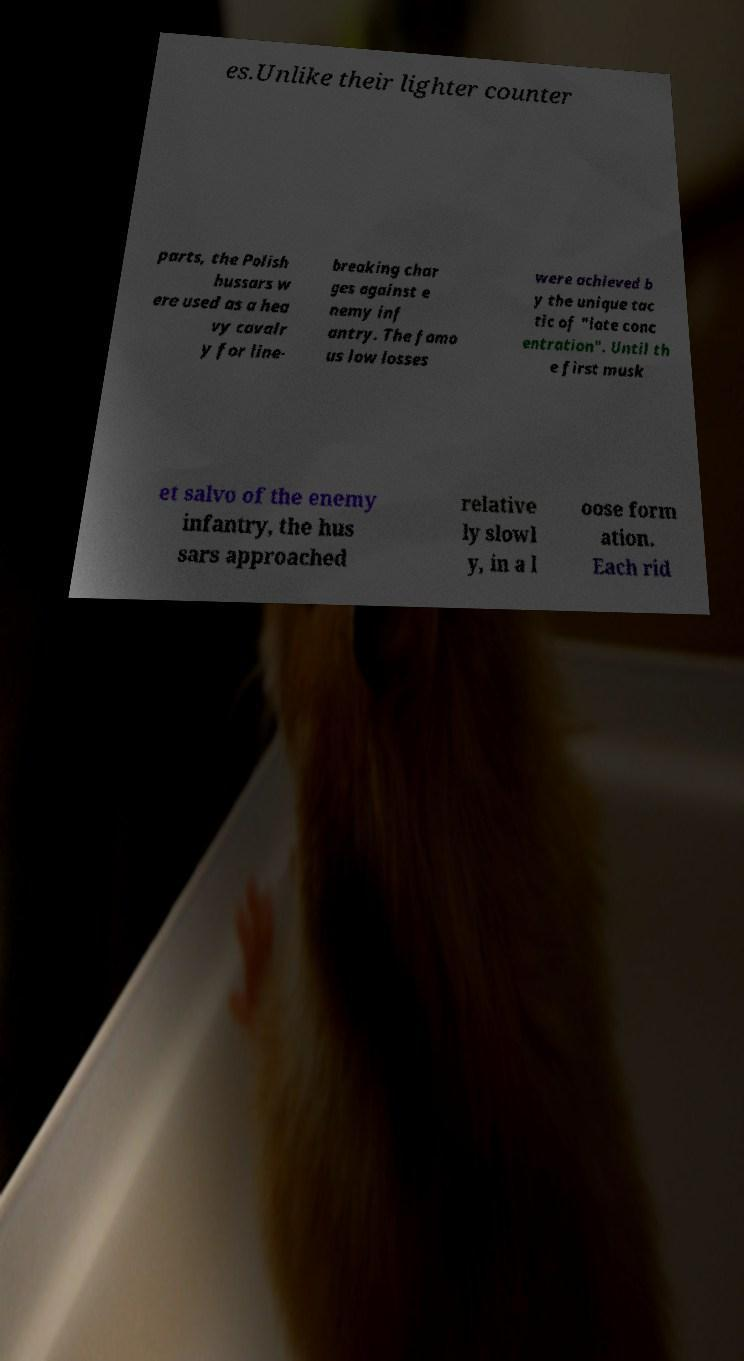Can you read and provide the text displayed in the image?This photo seems to have some interesting text. Can you extract and type it out for me? es.Unlike their lighter counter parts, the Polish hussars w ere used as a hea vy cavalr y for line- breaking char ges against e nemy inf antry. The famo us low losses were achieved b y the unique tac tic of "late conc entration". Until th e first musk et salvo of the enemy infantry, the hus sars approached relative ly slowl y, in a l oose form ation. Each rid 